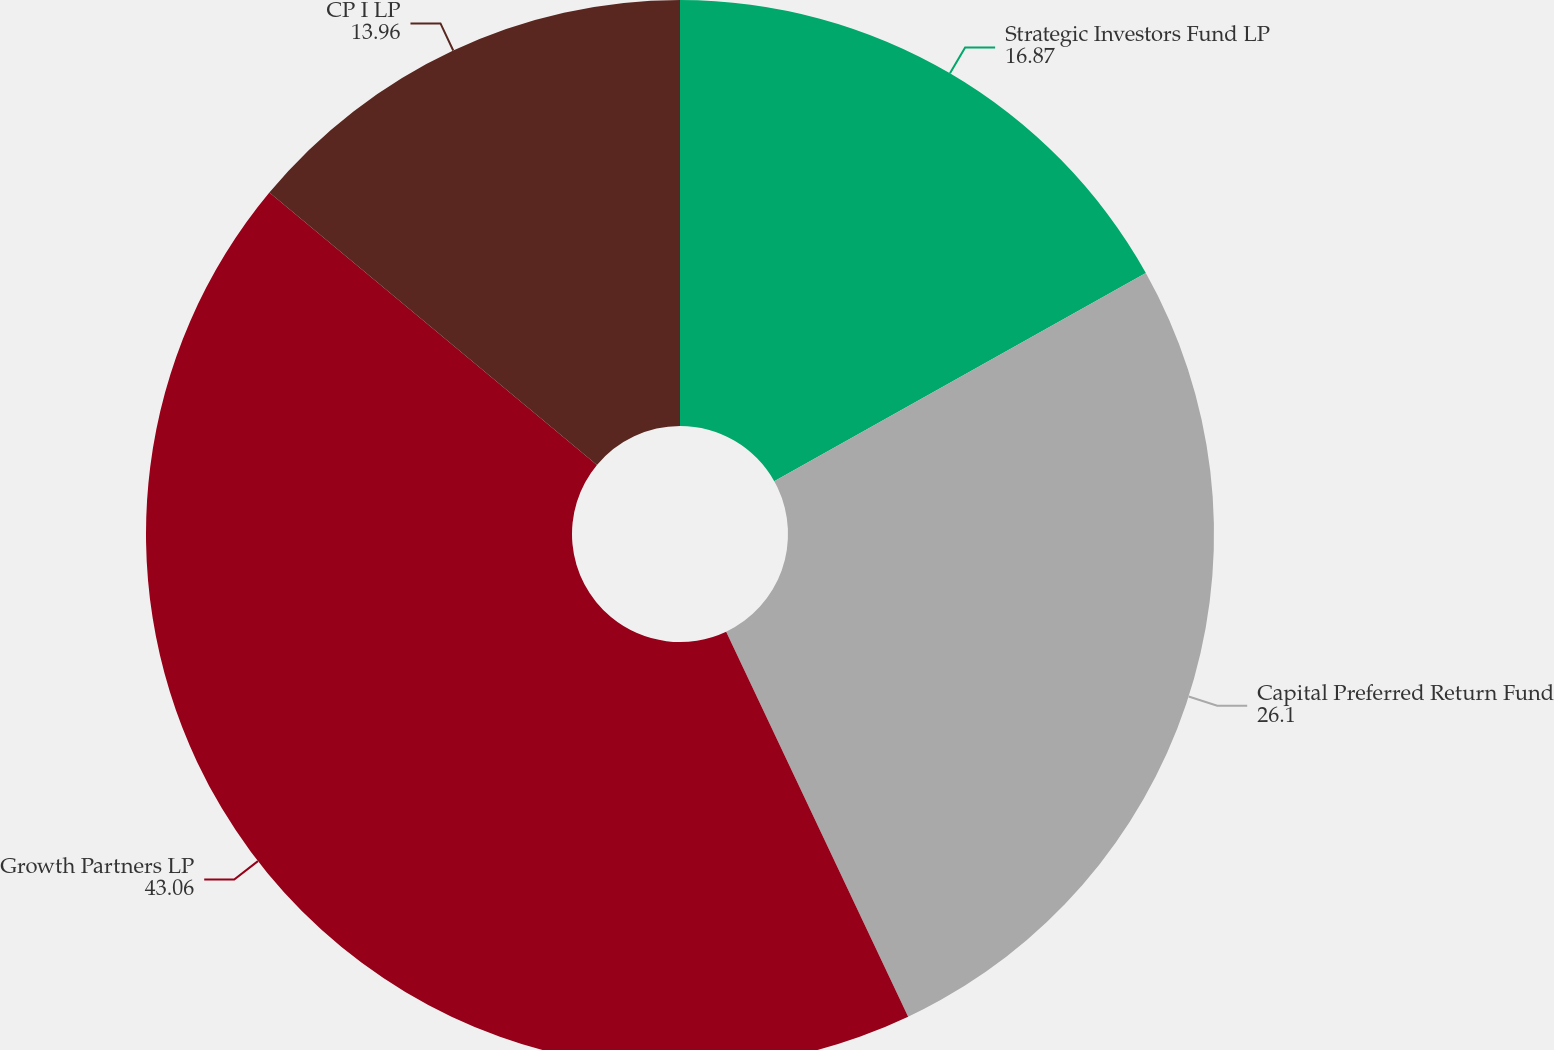Convert chart to OTSL. <chart><loc_0><loc_0><loc_500><loc_500><pie_chart><fcel>Strategic Investors Fund LP<fcel>Capital Preferred Return Fund<fcel>Growth Partners LP<fcel>CP I LP<nl><fcel>16.87%<fcel>26.1%<fcel>43.06%<fcel>13.96%<nl></chart> 